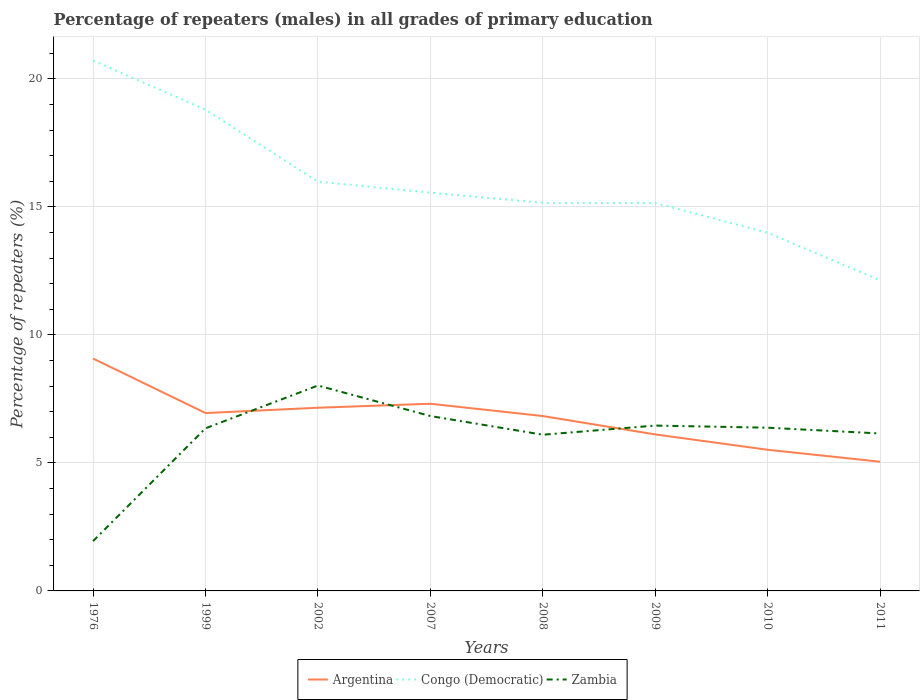Across all years, what is the maximum percentage of repeaters (males) in Congo (Democratic)?
Give a very brief answer. 12.13. In which year was the percentage of repeaters (males) in Argentina maximum?
Offer a terse response. 2011. What is the total percentage of repeaters (males) in Congo (Democratic) in the graph?
Ensure brevity in your answer.  3.86. What is the difference between the highest and the second highest percentage of repeaters (males) in Congo (Democratic)?
Make the answer very short. 8.58. What is the difference between the highest and the lowest percentage of repeaters (males) in Argentina?
Give a very brief answer. 5. How many lines are there?
Offer a very short reply. 3. Are the values on the major ticks of Y-axis written in scientific E-notation?
Ensure brevity in your answer.  No. Does the graph contain grids?
Your answer should be very brief. Yes. Where does the legend appear in the graph?
Provide a succinct answer. Bottom center. How many legend labels are there?
Make the answer very short. 3. What is the title of the graph?
Ensure brevity in your answer.  Percentage of repeaters (males) in all grades of primary education. What is the label or title of the X-axis?
Ensure brevity in your answer.  Years. What is the label or title of the Y-axis?
Give a very brief answer. Percentage of repeaters (%). What is the Percentage of repeaters (%) of Argentina in 1976?
Keep it short and to the point. 9.08. What is the Percentage of repeaters (%) in Congo (Democratic) in 1976?
Provide a succinct answer. 20.72. What is the Percentage of repeaters (%) of Zambia in 1976?
Ensure brevity in your answer.  1.95. What is the Percentage of repeaters (%) of Argentina in 1999?
Give a very brief answer. 6.95. What is the Percentage of repeaters (%) in Congo (Democratic) in 1999?
Keep it short and to the point. 18.8. What is the Percentage of repeaters (%) in Zambia in 1999?
Provide a short and direct response. 6.35. What is the Percentage of repeaters (%) in Argentina in 2002?
Your response must be concise. 7.16. What is the Percentage of repeaters (%) in Congo (Democratic) in 2002?
Provide a short and direct response. 15.99. What is the Percentage of repeaters (%) in Zambia in 2002?
Provide a succinct answer. 8.02. What is the Percentage of repeaters (%) in Argentina in 2007?
Your answer should be very brief. 7.31. What is the Percentage of repeaters (%) in Congo (Democratic) in 2007?
Your answer should be very brief. 15.56. What is the Percentage of repeaters (%) of Zambia in 2007?
Your answer should be compact. 6.83. What is the Percentage of repeaters (%) of Argentina in 2008?
Ensure brevity in your answer.  6.83. What is the Percentage of repeaters (%) in Congo (Democratic) in 2008?
Give a very brief answer. 15.16. What is the Percentage of repeaters (%) in Zambia in 2008?
Your answer should be compact. 6.1. What is the Percentage of repeaters (%) of Argentina in 2009?
Your answer should be compact. 6.11. What is the Percentage of repeaters (%) of Congo (Democratic) in 2009?
Give a very brief answer. 15.16. What is the Percentage of repeaters (%) in Zambia in 2009?
Offer a terse response. 6.46. What is the Percentage of repeaters (%) of Argentina in 2010?
Keep it short and to the point. 5.51. What is the Percentage of repeaters (%) of Congo (Democratic) in 2010?
Keep it short and to the point. 13.99. What is the Percentage of repeaters (%) of Zambia in 2010?
Offer a very short reply. 6.38. What is the Percentage of repeaters (%) of Argentina in 2011?
Offer a very short reply. 5.05. What is the Percentage of repeaters (%) of Congo (Democratic) in 2011?
Provide a short and direct response. 12.13. What is the Percentage of repeaters (%) in Zambia in 2011?
Keep it short and to the point. 6.15. Across all years, what is the maximum Percentage of repeaters (%) of Argentina?
Your answer should be compact. 9.08. Across all years, what is the maximum Percentage of repeaters (%) of Congo (Democratic)?
Offer a very short reply. 20.72. Across all years, what is the maximum Percentage of repeaters (%) in Zambia?
Your answer should be compact. 8.02. Across all years, what is the minimum Percentage of repeaters (%) of Argentina?
Ensure brevity in your answer.  5.05. Across all years, what is the minimum Percentage of repeaters (%) in Congo (Democratic)?
Your response must be concise. 12.13. Across all years, what is the minimum Percentage of repeaters (%) of Zambia?
Keep it short and to the point. 1.95. What is the total Percentage of repeaters (%) in Argentina in the graph?
Give a very brief answer. 54. What is the total Percentage of repeaters (%) of Congo (Democratic) in the graph?
Provide a succinct answer. 127.5. What is the total Percentage of repeaters (%) in Zambia in the graph?
Your response must be concise. 48.24. What is the difference between the Percentage of repeaters (%) in Argentina in 1976 and that in 1999?
Your answer should be very brief. 2.13. What is the difference between the Percentage of repeaters (%) in Congo (Democratic) in 1976 and that in 1999?
Your answer should be compact. 1.92. What is the difference between the Percentage of repeaters (%) of Zambia in 1976 and that in 1999?
Offer a terse response. -4.41. What is the difference between the Percentage of repeaters (%) in Argentina in 1976 and that in 2002?
Your answer should be compact. 1.92. What is the difference between the Percentage of repeaters (%) in Congo (Democratic) in 1976 and that in 2002?
Your answer should be very brief. 4.73. What is the difference between the Percentage of repeaters (%) of Zambia in 1976 and that in 2002?
Ensure brevity in your answer.  -6.08. What is the difference between the Percentage of repeaters (%) in Argentina in 1976 and that in 2007?
Ensure brevity in your answer.  1.77. What is the difference between the Percentage of repeaters (%) of Congo (Democratic) in 1976 and that in 2007?
Your response must be concise. 5.16. What is the difference between the Percentage of repeaters (%) in Zambia in 1976 and that in 2007?
Keep it short and to the point. -4.89. What is the difference between the Percentage of repeaters (%) in Argentina in 1976 and that in 2008?
Make the answer very short. 2.25. What is the difference between the Percentage of repeaters (%) in Congo (Democratic) in 1976 and that in 2008?
Give a very brief answer. 5.56. What is the difference between the Percentage of repeaters (%) in Zambia in 1976 and that in 2008?
Ensure brevity in your answer.  -4.16. What is the difference between the Percentage of repeaters (%) of Argentina in 1976 and that in 2009?
Your answer should be compact. 2.96. What is the difference between the Percentage of repeaters (%) of Congo (Democratic) in 1976 and that in 2009?
Your answer should be very brief. 5.56. What is the difference between the Percentage of repeaters (%) of Zambia in 1976 and that in 2009?
Offer a terse response. -4.51. What is the difference between the Percentage of repeaters (%) in Argentina in 1976 and that in 2010?
Your answer should be compact. 3.56. What is the difference between the Percentage of repeaters (%) in Congo (Democratic) in 1976 and that in 2010?
Provide a succinct answer. 6.72. What is the difference between the Percentage of repeaters (%) in Zambia in 1976 and that in 2010?
Offer a very short reply. -4.43. What is the difference between the Percentage of repeaters (%) of Argentina in 1976 and that in 2011?
Provide a short and direct response. 4.03. What is the difference between the Percentage of repeaters (%) of Congo (Democratic) in 1976 and that in 2011?
Make the answer very short. 8.58. What is the difference between the Percentage of repeaters (%) of Zambia in 1976 and that in 2011?
Provide a short and direct response. -4.21. What is the difference between the Percentage of repeaters (%) in Argentina in 1999 and that in 2002?
Keep it short and to the point. -0.21. What is the difference between the Percentage of repeaters (%) of Congo (Democratic) in 1999 and that in 2002?
Provide a short and direct response. 2.81. What is the difference between the Percentage of repeaters (%) of Zambia in 1999 and that in 2002?
Provide a succinct answer. -1.67. What is the difference between the Percentage of repeaters (%) of Argentina in 1999 and that in 2007?
Provide a short and direct response. -0.36. What is the difference between the Percentage of repeaters (%) in Congo (Democratic) in 1999 and that in 2007?
Your response must be concise. 3.24. What is the difference between the Percentage of repeaters (%) of Zambia in 1999 and that in 2007?
Keep it short and to the point. -0.48. What is the difference between the Percentage of repeaters (%) in Argentina in 1999 and that in 2008?
Ensure brevity in your answer.  0.12. What is the difference between the Percentage of repeaters (%) of Congo (Democratic) in 1999 and that in 2008?
Your answer should be very brief. 3.64. What is the difference between the Percentage of repeaters (%) in Zambia in 1999 and that in 2008?
Offer a terse response. 0.25. What is the difference between the Percentage of repeaters (%) of Argentina in 1999 and that in 2009?
Give a very brief answer. 0.84. What is the difference between the Percentage of repeaters (%) of Congo (Democratic) in 1999 and that in 2009?
Offer a very short reply. 3.64. What is the difference between the Percentage of repeaters (%) in Zambia in 1999 and that in 2009?
Your response must be concise. -0.11. What is the difference between the Percentage of repeaters (%) of Argentina in 1999 and that in 2010?
Provide a succinct answer. 1.43. What is the difference between the Percentage of repeaters (%) in Congo (Democratic) in 1999 and that in 2010?
Make the answer very short. 4.81. What is the difference between the Percentage of repeaters (%) of Zambia in 1999 and that in 2010?
Ensure brevity in your answer.  -0.02. What is the difference between the Percentage of repeaters (%) of Argentina in 1999 and that in 2011?
Make the answer very short. 1.9. What is the difference between the Percentage of repeaters (%) in Congo (Democratic) in 1999 and that in 2011?
Provide a short and direct response. 6.67. What is the difference between the Percentage of repeaters (%) in Zambia in 1999 and that in 2011?
Provide a succinct answer. 0.2. What is the difference between the Percentage of repeaters (%) of Argentina in 2002 and that in 2007?
Your answer should be compact. -0.16. What is the difference between the Percentage of repeaters (%) in Congo (Democratic) in 2002 and that in 2007?
Offer a very short reply. 0.43. What is the difference between the Percentage of repeaters (%) in Zambia in 2002 and that in 2007?
Your answer should be compact. 1.19. What is the difference between the Percentage of repeaters (%) in Argentina in 2002 and that in 2008?
Make the answer very short. 0.33. What is the difference between the Percentage of repeaters (%) of Congo (Democratic) in 2002 and that in 2008?
Offer a terse response. 0.83. What is the difference between the Percentage of repeaters (%) in Zambia in 2002 and that in 2008?
Provide a succinct answer. 1.92. What is the difference between the Percentage of repeaters (%) in Argentina in 2002 and that in 2009?
Your answer should be very brief. 1.04. What is the difference between the Percentage of repeaters (%) in Congo (Democratic) in 2002 and that in 2009?
Keep it short and to the point. 0.83. What is the difference between the Percentage of repeaters (%) in Zambia in 2002 and that in 2009?
Keep it short and to the point. 1.56. What is the difference between the Percentage of repeaters (%) of Argentina in 2002 and that in 2010?
Give a very brief answer. 1.64. What is the difference between the Percentage of repeaters (%) in Congo (Democratic) in 2002 and that in 2010?
Make the answer very short. 2. What is the difference between the Percentage of repeaters (%) in Zambia in 2002 and that in 2010?
Offer a very short reply. 1.65. What is the difference between the Percentage of repeaters (%) of Argentina in 2002 and that in 2011?
Your answer should be very brief. 2.11. What is the difference between the Percentage of repeaters (%) of Congo (Democratic) in 2002 and that in 2011?
Make the answer very short. 3.86. What is the difference between the Percentage of repeaters (%) of Zambia in 2002 and that in 2011?
Your answer should be very brief. 1.87. What is the difference between the Percentage of repeaters (%) of Argentina in 2007 and that in 2008?
Keep it short and to the point. 0.48. What is the difference between the Percentage of repeaters (%) of Congo (Democratic) in 2007 and that in 2008?
Provide a succinct answer. 0.4. What is the difference between the Percentage of repeaters (%) in Zambia in 2007 and that in 2008?
Your answer should be compact. 0.73. What is the difference between the Percentage of repeaters (%) in Argentina in 2007 and that in 2009?
Offer a terse response. 1.2. What is the difference between the Percentage of repeaters (%) in Congo (Democratic) in 2007 and that in 2009?
Provide a succinct answer. 0.4. What is the difference between the Percentage of repeaters (%) in Zambia in 2007 and that in 2009?
Make the answer very short. 0.37. What is the difference between the Percentage of repeaters (%) of Argentina in 2007 and that in 2010?
Offer a very short reply. 1.8. What is the difference between the Percentage of repeaters (%) of Congo (Democratic) in 2007 and that in 2010?
Make the answer very short. 1.56. What is the difference between the Percentage of repeaters (%) of Zambia in 2007 and that in 2010?
Provide a short and direct response. 0.46. What is the difference between the Percentage of repeaters (%) in Argentina in 2007 and that in 2011?
Your response must be concise. 2.26. What is the difference between the Percentage of repeaters (%) of Congo (Democratic) in 2007 and that in 2011?
Your response must be concise. 3.42. What is the difference between the Percentage of repeaters (%) of Zambia in 2007 and that in 2011?
Provide a short and direct response. 0.68. What is the difference between the Percentage of repeaters (%) of Argentina in 2008 and that in 2009?
Give a very brief answer. 0.72. What is the difference between the Percentage of repeaters (%) of Congo (Democratic) in 2008 and that in 2009?
Ensure brevity in your answer.  0. What is the difference between the Percentage of repeaters (%) in Zambia in 2008 and that in 2009?
Offer a very short reply. -0.36. What is the difference between the Percentage of repeaters (%) of Argentina in 2008 and that in 2010?
Provide a succinct answer. 1.32. What is the difference between the Percentage of repeaters (%) in Congo (Democratic) in 2008 and that in 2010?
Make the answer very short. 1.17. What is the difference between the Percentage of repeaters (%) of Zambia in 2008 and that in 2010?
Provide a succinct answer. -0.27. What is the difference between the Percentage of repeaters (%) of Argentina in 2008 and that in 2011?
Offer a very short reply. 1.78. What is the difference between the Percentage of repeaters (%) in Congo (Democratic) in 2008 and that in 2011?
Provide a succinct answer. 3.03. What is the difference between the Percentage of repeaters (%) of Zambia in 2008 and that in 2011?
Keep it short and to the point. -0.05. What is the difference between the Percentage of repeaters (%) in Argentina in 2009 and that in 2010?
Make the answer very short. 0.6. What is the difference between the Percentage of repeaters (%) in Congo (Democratic) in 2009 and that in 2010?
Your answer should be compact. 1.16. What is the difference between the Percentage of repeaters (%) in Zambia in 2009 and that in 2010?
Your answer should be compact. 0.08. What is the difference between the Percentage of repeaters (%) in Argentina in 2009 and that in 2011?
Offer a very short reply. 1.07. What is the difference between the Percentage of repeaters (%) in Congo (Democratic) in 2009 and that in 2011?
Make the answer very short. 3.02. What is the difference between the Percentage of repeaters (%) in Zambia in 2009 and that in 2011?
Make the answer very short. 0.31. What is the difference between the Percentage of repeaters (%) in Argentina in 2010 and that in 2011?
Your response must be concise. 0.47. What is the difference between the Percentage of repeaters (%) in Congo (Democratic) in 2010 and that in 2011?
Your response must be concise. 1.86. What is the difference between the Percentage of repeaters (%) in Zambia in 2010 and that in 2011?
Provide a short and direct response. 0.23. What is the difference between the Percentage of repeaters (%) of Argentina in 1976 and the Percentage of repeaters (%) of Congo (Democratic) in 1999?
Your answer should be very brief. -9.72. What is the difference between the Percentage of repeaters (%) of Argentina in 1976 and the Percentage of repeaters (%) of Zambia in 1999?
Offer a terse response. 2.72. What is the difference between the Percentage of repeaters (%) in Congo (Democratic) in 1976 and the Percentage of repeaters (%) in Zambia in 1999?
Offer a terse response. 14.36. What is the difference between the Percentage of repeaters (%) in Argentina in 1976 and the Percentage of repeaters (%) in Congo (Democratic) in 2002?
Provide a short and direct response. -6.91. What is the difference between the Percentage of repeaters (%) of Argentina in 1976 and the Percentage of repeaters (%) of Zambia in 2002?
Provide a succinct answer. 1.05. What is the difference between the Percentage of repeaters (%) in Congo (Democratic) in 1976 and the Percentage of repeaters (%) in Zambia in 2002?
Your response must be concise. 12.69. What is the difference between the Percentage of repeaters (%) in Argentina in 1976 and the Percentage of repeaters (%) in Congo (Democratic) in 2007?
Offer a terse response. -6.48. What is the difference between the Percentage of repeaters (%) in Argentina in 1976 and the Percentage of repeaters (%) in Zambia in 2007?
Offer a very short reply. 2.25. What is the difference between the Percentage of repeaters (%) of Congo (Democratic) in 1976 and the Percentage of repeaters (%) of Zambia in 2007?
Make the answer very short. 13.89. What is the difference between the Percentage of repeaters (%) of Argentina in 1976 and the Percentage of repeaters (%) of Congo (Democratic) in 2008?
Ensure brevity in your answer.  -6.08. What is the difference between the Percentage of repeaters (%) of Argentina in 1976 and the Percentage of repeaters (%) of Zambia in 2008?
Give a very brief answer. 2.98. What is the difference between the Percentage of repeaters (%) in Congo (Democratic) in 1976 and the Percentage of repeaters (%) in Zambia in 2008?
Your response must be concise. 14.62. What is the difference between the Percentage of repeaters (%) in Argentina in 1976 and the Percentage of repeaters (%) in Congo (Democratic) in 2009?
Your response must be concise. -6.08. What is the difference between the Percentage of repeaters (%) in Argentina in 1976 and the Percentage of repeaters (%) in Zambia in 2009?
Your answer should be compact. 2.62. What is the difference between the Percentage of repeaters (%) of Congo (Democratic) in 1976 and the Percentage of repeaters (%) of Zambia in 2009?
Your answer should be compact. 14.26. What is the difference between the Percentage of repeaters (%) of Argentina in 1976 and the Percentage of repeaters (%) of Congo (Democratic) in 2010?
Offer a very short reply. -4.92. What is the difference between the Percentage of repeaters (%) of Argentina in 1976 and the Percentage of repeaters (%) of Zambia in 2010?
Offer a very short reply. 2.7. What is the difference between the Percentage of repeaters (%) in Congo (Democratic) in 1976 and the Percentage of repeaters (%) in Zambia in 2010?
Your answer should be compact. 14.34. What is the difference between the Percentage of repeaters (%) in Argentina in 1976 and the Percentage of repeaters (%) in Congo (Democratic) in 2011?
Your answer should be compact. -3.06. What is the difference between the Percentage of repeaters (%) in Argentina in 1976 and the Percentage of repeaters (%) in Zambia in 2011?
Your answer should be compact. 2.93. What is the difference between the Percentage of repeaters (%) of Congo (Democratic) in 1976 and the Percentage of repeaters (%) of Zambia in 2011?
Keep it short and to the point. 14.57. What is the difference between the Percentage of repeaters (%) of Argentina in 1999 and the Percentage of repeaters (%) of Congo (Democratic) in 2002?
Make the answer very short. -9.04. What is the difference between the Percentage of repeaters (%) of Argentina in 1999 and the Percentage of repeaters (%) of Zambia in 2002?
Ensure brevity in your answer.  -1.08. What is the difference between the Percentage of repeaters (%) of Congo (Democratic) in 1999 and the Percentage of repeaters (%) of Zambia in 2002?
Provide a short and direct response. 10.77. What is the difference between the Percentage of repeaters (%) in Argentina in 1999 and the Percentage of repeaters (%) in Congo (Democratic) in 2007?
Your answer should be very brief. -8.61. What is the difference between the Percentage of repeaters (%) of Argentina in 1999 and the Percentage of repeaters (%) of Zambia in 2007?
Give a very brief answer. 0.12. What is the difference between the Percentage of repeaters (%) of Congo (Democratic) in 1999 and the Percentage of repeaters (%) of Zambia in 2007?
Make the answer very short. 11.97. What is the difference between the Percentage of repeaters (%) in Argentina in 1999 and the Percentage of repeaters (%) in Congo (Democratic) in 2008?
Your answer should be very brief. -8.21. What is the difference between the Percentage of repeaters (%) in Argentina in 1999 and the Percentage of repeaters (%) in Zambia in 2008?
Provide a succinct answer. 0.85. What is the difference between the Percentage of repeaters (%) in Congo (Democratic) in 1999 and the Percentage of repeaters (%) in Zambia in 2008?
Offer a terse response. 12.7. What is the difference between the Percentage of repeaters (%) in Argentina in 1999 and the Percentage of repeaters (%) in Congo (Democratic) in 2009?
Give a very brief answer. -8.21. What is the difference between the Percentage of repeaters (%) of Argentina in 1999 and the Percentage of repeaters (%) of Zambia in 2009?
Offer a very short reply. 0.49. What is the difference between the Percentage of repeaters (%) in Congo (Democratic) in 1999 and the Percentage of repeaters (%) in Zambia in 2009?
Your answer should be very brief. 12.34. What is the difference between the Percentage of repeaters (%) of Argentina in 1999 and the Percentage of repeaters (%) of Congo (Democratic) in 2010?
Ensure brevity in your answer.  -7.04. What is the difference between the Percentage of repeaters (%) of Argentina in 1999 and the Percentage of repeaters (%) of Zambia in 2010?
Ensure brevity in your answer.  0.57. What is the difference between the Percentage of repeaters (%) in Congo (Democratic) in 1999 and the Percentage of repeaters (%) in Zambia in 2010?
Provide a short and direct response. 12.42. What is the difference between the Percentage of repeaters (%) in Argentina in 1999 and the Percentage of repeaters (%) in Congo (Democratic) in 2011?
Your answer should be compact. -5.18. What is the difference between the Percentage of repeaters (%) in Argentina in 1999 and the Percentage of repeaters (%) in Zambia in 2011?
Give a very brief answer. 0.8. What is the difference between the Percentage of repeaters (%) of Congo (Democratic) in 1999 and the Percentage of repeaters (%) of Zambia in 2011?
Your response must be concise. 12.65. What is the difference between the Percentage of repeaters (%) in Argentina in 2002 and the Percentage of repeaters (%) in Congo (Democratic) in 2007?
Keep it short and to the point. -8.4. What is the difference between the Percentage of repeaters (%) of Argentina in 2002 and the Percentage of repeaters (%) of Zambia in 2007?
Offer a terse response. 0.32. What is the difference between the Percentage of repeaters (%) in Congo (Democratic) in 2002 and the Percentage of repeaters (%) in Zambia in 2007?
Provide a succinct answer. 9.16. What is the difference between the Percentage of repeaters (%) in Argentina in 2002 and the Percentage of repeaters (%) in Congo (Democratic) in 2008?
Your response must be concise. -8. What is the difference between the Percentage of repeaters (%) of Argentina in 2002 and the Percentage of repeaters (%) of Zambia in 2008?
Provide a short and direct response. 1.05. What is the difference between the Percentage of repeaters (%) of Congo (Democratic) in 2002 and the Percentage of repeaters (%) of Zambia in 2008?
Your answer should be very brief. 9.89. What is the difference between the Percentage of repeaters (%) of Argentina in 2002 and the Percentage of repeaters (%) of Congo (Democratic) in 2009?
Provide a succinct answer. -8. What is the difference between the Percentage of repeaters (%) in Argentina in 2002 and the Percentage of repeaters (%) in Zambia in 2009?
Your response must be concise. 0.7. What is the difference between the Percentage of repeaters (%) of Congo (Democratic) in 2002 and the Percentage of repeaters (%) of Zambia in 2009?
Ensure brevity in your answer.  9.53. What is the difference between the Percentage of repeaters (%) of Argentina in 2002 and the Percentage of repeaters (%) of Congo (Democratic) in 2010?
Offer a very short reply. -6.84. What is the difference between the Percentage of repeaters (%) of Argentina in 2002 and the Percentage of repeaters (%) of Zambia in 2010?
Ensure brevity in your answer.  0.78. What is the difference between the Percentage of repeaters (%) of Congo (Democratic) in 2002 and the Percentage of repeaters (%) of Zambia in 2010?
Provide a succinct answer. 9.61. What is the difference between the Percentage of repeaters (%) in Argentina in 2002 and the Percentage of repeaters (%) in Congo (Democratic) in 2011?
Keep it short and to the point. -4.98. What is the difference between the Percentage of repeaters (%) in Congo (Democratic) in 2002 and the Percentage of repeaters (%) in Zambia in 2011?
Ensure brevity in your answer.  9.84. What is the difference between the Percentage of repeaters (%) of Argentina in 2007 and the Percentage of repeaters (%) of Congo (Democratic) in 2008?
Offer a terse response. -7.85. What is the difference between the Percentage of repeaters (%) in Argentina in 2007 and the Percentage of repeaters (%) in Zambia in 2008?
Keep it short and to the point. 1.21. What is the difference between the Percentage of repeaters (%) in Congo (Democratic) in 2007 and the Percentage of repeaters (%) in Zambia in 2008?
Your answer should be compact. 9.46. What is the difference between the Percentage of repeaters (%) of Argentina in 2007 and the Percentage of repeaters (%) of Congo (Democratic) in 2009?
Provide a short and direct response. -7.84. What is the difference between the Percentage of repeaters (%) in Argentina in 2007 and the Percentage of repeaters (%) in Zambia in 2009?
Ensure brevity in your answer.  0.85. What is the difference between the Percentage of repeaters (%) in Congo (Democratic) in 2007 and the Percentage of repeaters (%) in Zambia in 2009?
Provide a short and direct response. 9.1. What is the difference between the Percentage of repeaters (%) in Argentina in 2007 and the Percentage of repeaters (%) in Congo (Democratic) in 2010?
Your answer should be very brief. -6.68. What is the difference between the Percentage of repeaters (%) of Argentina in 2007 and the Percentage of repeaters (%) of Zambia in 2010?
Offer a terse response. 0.94. What is the difference between the Percentage of repeaters (%) of Congo (Democratic) in 2007 and the Percentage of repeaters (%) of Zambia in 2010?
Your answer should be compact. 9.18. What is the difference between the Percentage of repeaters (%) in Argentina in 2007 and the Percentage of repeaters (%) in Congo (Democratic) in 2011?
Offer a terse response. -4.82. What is the difference between the Percentage of repeaters (%) of Argentina in 2007 and the Percentage of repeaters (%) of Zambia in 2011?
Your response must be concise. 1.16. What is the difference between the Percentage of repeaters (%) of Congo (Democratic) in 2007 and the Percentage of repeaters (%) of Zambia in 2011?
Your response must be concise. 9.41. What is the difference between the Percentage of repeaters (%) in Argentina in 2008 and the Percentage of repeaters (%) in Congo (Democratic) in 2009?
Give a very brief answer. -8.32. What is the difference between the Percentage of repeaters (%) in Argentina in 2008 and the Percentage of repeaters (%) in Zambia in 2009?
Make the answer very short. 0.37. What is the difference between the Percentage of repeaters (%) in Congo (Democratic) in 2008 and the Percentage of repeaters (%) in Zambia in 2009?
Your answer should be compact. 8.7. What is the difference between the Percentage of repeaters (%) in Argentina in 2008 and the Percentage of repeaters (%) in Congo (Democratic) in 2010?
Give a very brief answer. -7.16. What is the difference between the Percentage of repeaters (%) of Argentina in 2008 and the Percentage of repeaters (%) of Zambia in 2010?
Provide a short and direct response. 0.45. What is the difference between the Percentage of repeaters (%) of Congo (Democratic) in 2008 and the Percentage of repeaters (%) of Zambia in 2010?
Keep it short and to the point. 8.78. What is the difference between the Percentage of repeaters (%) in Argentina in 2008 and the Percentage of repeaters (%) in Congo (Democratic) in 2011?
Provide a succinct answer. -5.3. What is the difference between the Percentage of repeaters (%) in Argentina in 2008 and the Percentage of repeaters (%) in Zambia in 2011?
Your response must be concise. 0.68. What is the difference between the Percentage of repeaters (%) of Congo (Democratic) in 2008 and the Percentage of repeaters (%) of Zambia in 2011?
Your response must be concise. 9.01. What is the difference between the Percentage of repeaters (%) in Argentina in 2009 and the Percentage of repeaters (%) in Congo (Democratic) in 2010?
Your response must be concise. -7.88. What is the difference between the Percentage of repeaters (%) of Argentina in 2009 and the Percentage of repeaters (%) of Zambia in 2010?
Offer a terse response. -0.26. What is the difference between the Percentage of repeaters (%) in Congo (Democratic) in 2009 and the Percentage of repeaters (%) in Zambia in 2010?
Your answer should be compact. 8.78. What is the difference between the Percentage of repeaters (%) of Argentina in 2009 and the Percentage of repeaters (%) of Congo (Democratic) in 2011?
Your response must be concise. -6.02. What is the difference between the Percentage of repeaters (%) in Argentina in 2009 and the Percentage of repeaters (%) in Zambia in 2011?
Keep it short and to the point. -0.04. What is the difference between the Percentage of repeaters (%) of Congo (Democratic) in 2009 and the Percentage of repeaters (%) of Zambia in 2011?
Keep it short and to the point. 9.01. What is the difference between the Percentage of repeaters (%) of Argentina in 2010 and the Percentage of repeaters (%) of Congo (Democratic) in 2011?
Offer a terse response. -6.62. What is the difference between the Percentage of repeaters (%) in Argentina in 2010 and the Percentage of repeaters (%) in Zambia in 2011?
Provide a short and direct response. -0.64. What is the difference between the Percentage of repeaters (%) of Congo (Democratic) in 2010 and the Percentage of repeaters (%) of Zambia in 2011?
Your response must be concise. 7.84. What is the average Percentage of repeaters (%) of Argentina per year?
Your answer should be compact. 6.75. What is the average Percentage of repeaters (%) of Congo (Democratic) per year?
Your answer should be compact. 15.94. What is the average Percentage of repeaters (%) of Zambia per year?
Ensure brevity in your answer.  6.03. In the year 1976, what is the difference between the Percentage of repeaters (%) in Argentina and Percentage of repeaters (%) in Congo (Democratic)?
Give a very brief answer. -11.64. In the year 1976, what is the difference between the Percentage of repeaters (%) of Argentina and Percentage of repeaters (%) of Zambia?
Keep it short and to the point. 7.13. In the year 1976, what is the difference between the Percentage of repeaters (%) in Congo (Democratic) and Percentage of repeaters (%) in Zambia?
Provide a short and direct response. 18.77. In the year 1999, what is the difference between the Percentage of repeaters (%) of Argentina and Percentage of repeaters (%) of Congo (Democratic)?
Offer a very short reply. -11.85. In the year 1999, what is the difference between the Percentage of repeaters (%) of Argentina and Percentage of repeaters (%) of Zambia?
Keep it short and to the point. 0.6. In the year 1999, what is the difference between the Percentage of repeaters (%) in Congo (Democratic) and Percentage of repeaters (%) in Zambia?
Keep it short and to the point. 12.45. In the year 2002, what is the difference between the Percentage of repeaters (%) in Argentina and Percentage of repeaters (%) in Congo (Democratic)?
Keep it short and to the point. -8.83. In the year 2002, what is the difference between the Percentage of repeaters (%) in Argentina and Percentage of repeaters (%) in Zambia?
Make the answer very short. -0.87. In the year 2002, what is the difference between the Percentage of repeaters (%) of Congo (Democratic) and Percentage of repeaters (%) of Zambia?
Your answer should be compact. 7.96. In the year 2007, what is the difference between the Percentage of repeaters (%) of Argentina and Percentage of repeaters (%) of Congo (Democratic)?
Provide a short and direct response. -8.25. In the year 2007, what is the difference between the Percentage of repeaters (%) of Argentina and Percentage of repeaters (%) of Zambia?
Make the answer very short. 0.48. In the year 2007, what is the difference between the Percentage of repeaters (%) in Congo (Democratic) and Percentage of repeaters (%) in Zambia?
Offer a terse response. 8.73. In the year 2008, what is the difference between the Percentage of repeaters (%) of Argentina and Percentage of repeaters (%) of Congo (Democratic)?
Your answer should be very brief. -8.33. In the year 2008, what is the difference between the Percentage of repeaters (%) in Argentina and Percentage of repeaters (%) in Zambia?
Offer a terse response. 0.73. In the year 2008, what is the difference between the Percentage of repeaters (%) of Congo (Democratic) and Percentage of repeaters (%) of Zambia?
Your response must be concise. 9.06. In the year 2009, what is the difference between the Percentage of repeaters (%) in Argentina and Percentage of repeaters (%) in Congo (Democratic)?
Ensure brevity in your answer.  -9.04. In the year 2009, what is the difference between the Percentage of repeaters (%) in Argentina and Percentage of repeaters (%) in Zambia?
Your answer should be compact. -0.35. In the year 2009, what is the difference between the Percentage of repeaters (%) in Congo (Democratic) and Percentage of repeaters (%) in Zambia?
Give a very brief answer. 8.7. In the year 2010, what is the difference between the Percentage of repeaters (%) of Argentina and Percentage of repeaters (%) of Congo (Democratic)?
Keep it short and to the point. -8.48. In the year 2010, what is the difference between the Percentage of repeaters (%) in Argentina and Percentage of repeaters (%) in Zambia?
Ensure brevity in your answer.  -0.86. In the year 2010, what is the difference between the Percentage of repeaters (%) of Congo (Democratic) and Percentage of repeaters (%) of Zambia?
Provide a short and direct response. 7.62. In the year 2011, what is the difference between the Percentage of repeaters (%) of Argentina and Percentage of repeaters (%) of Congo (Democratic)?
Keep it short and to the point. -7.09. In the year 2011, what is the difference between the Percentage of repeaters (%) in Argentina and Percentage of repeaters (%) in Zambia?
Make the answer very short. -1.1. In the year 2011, what is the difference between the Percentage of repeaters (%) of Congo (Democratic) and Percentage of repeaters (%) of Zambia?
Keep it short and to the point. 5.98. What is the ratio of the Percentage of repeaters (%) of Argentina in 1976 to that in 1999?
Keep it short and to the point. 1.31. What is the ratio of the Percentage of repeaters (%) of Congo (Democratic) in 1976 to that in 1999?
Give a very brief answer. 1.1. What is the ratio of the Percentage of repeaters (%) of Zambia in 1976 to that in 1999?
Your answer should be very brief. 0.31. What is the ratio of the Percentage of repeaters (%) of Argentina in 1976 to that in 2002?
Offer a very short reply. 1.27. What is the ratio of the Percentage of repeaters (%) in Congo (Democratic) in 1976 to that in 2002?
Give a very brief answer. 1.3. What is the ratio of the Percentage of repeaters (%) in Zambia in 1976 to that in 2002?
Offer a very short reply. 0.24. What is the ratio of the Percentage of repeaters (%) in Argentina in 1976 to that in 2007?
Provide a succinct answer. 1.24. What is the ratio of the Percentage of repeaters (%) in Congo (Democratic) in 1976 to that in 2007?
Offer a very short reply. 1.33. What is the ratio of the Percentage of repeaters (%) of Zambia in 1976 to that in 2007?
Ensure brevity in your answer.  0.28. What is the ratio of the Percentage of repeaters (%) in Argentina in 1976 to that in 2008?
Your answer should be compact. 1.33. What is the ratio of the Percentage of repeaters (%) in Congo (Democratic) in 1976 to that in 2008?
Make the answer very short. 1.37. What is the ratio of the Percentage of repeaters (%) of Zambia in 1976 to that in 2008?
Provide a succinct answer. 0.32. What is the ratio of the Percentage of repeaters (%) of Argentina in 1976 to that in 2009?
Your answer should be very brief. 1.48. What is the ratio of the Percentage of repeaters (%) of Congo (Democratic) in 1976 to that in 2009?
Your answer should be compact. 1.37. What is the ratio of the Percentage of repeaters (%) in Zambia in 1976 to that in 2009?
Your answer should be very brief. 0.3. What is the ratio of the Percentage of repeaters (%) in Argentina in 1976 to that in 2010?
Offer a very short reply. 1.65. What is the ratio of the Percentage of repeaters (%) in Congo (Democratic) in 1976 to that in 2010?
Offer a terse response. 1.48. What is the ratio of the Percentage of repeaters (%) in Zambia in 1976 to that in 2010?
Offer a terse response. 0.31. What is the ratio of the Percentage of repeaters (%) in Argentina in 1976 to that in 2011?
Provide a short and direct response. 1.8. What is the ratio of the Percentage of repeaters (%) in Congo (Democratic) in 1976 to that in 2011?
Make the answer very short. 1.71. What is the ratio of the Percentage of repeaters (%) in Zambia in 1976 to that in 2011?
Offer a terse response. 0.32. What is the ratio of the Percentage of repeaters (%) in Argentina in 1999 to that in 2002?
Make the answer very short. 0.97. What is the ratio of the Percentage of repeaters (%) of Congo (Democratic) in 1999 to that in 2002?
Offer a terse response. 1.18. What is the ratio of the Percentage of repeaters (%) in Zambia in 1999 to that in 2002?
Your answer should be very brief. 0.79. What is the ratio of the Percentage of repeaters (%) in Argentina in 1999 to that in 2007?
Give a very brief answer. 0.95. What is the ratio of the Percentage of repeaters (%) in Congo (Democratic) in 1999 to that in 2007?
Give a very brief answer. 1.21. What is the ratio of the Percentage of repeaters (%) of Zambia in 1999 to that in 2007?
Offer a terse response. 0.93. What is the ratio of the Percentage of repeaters (%) in Argentina in 1999 to that in 2008?
Make the answer very short. 1.02. What is the ratio of the Percentage of repeaters (%) of Congo (Democratic) in 1999 to that in 2008?
Provide a short and direct response. 1.24. What is the ratio of the Percentage of repeaters (%) in Zambia in 1999 to that in 2008?
Keep it short and to the point. 1.04. What is the ratio of the Percentage of repeaters (%) in Argentina in 1999 to that in 2009?
Give a very brief answer. 1.14. What is the ratio of the Percentage of repeaters (%) of Congo (Democratic) in 1999 to that in 2009?
Give a very brief answer. 1.24. What is the ratio of the Percentage of repeaters (%) of Zambia in 1999 to that in 2009?
Offer a very short reply. 0.98. What is the ratio of the Percentage of repeaters (%) of Argentina in 1999 to that in 2010?
Give a very brief answer. 1.26. What is the ratio of the Percentage of repeaters (%) of Congo (Democratic) in 1999 to that in 2010?
Provide a succinct answer. 1.34. What is the ratio of the Percentage of repeaters (%) of Zambia in 1999 to that in 2010?
Give a very brief answer. 1. What is the ratio of the Percentage of repeaters (%) in Argentina in 1999 to that in 2011?
Give a very brief answer. 1.38. What is the ratio of the Percentage of repeaters (%) of Congo (Democratic) in 1999 to that in 2011?
Your answer should be compact. 1.55. What is the ratio of the Percentage of repeaters (%) of Zambia in 1999 to that in 2011?
Give a very brief answer. 1.03. What is the ratio of the Percentage of repeaters (%) in Argentina in 2002 to that in 2007?
Keep it short and to the point. 0.98. What is the ratio of the Percentage of repeaters (%) of Congo (Democratic) in 2002 to that in 2007?
Provide a short and direct response. 1.03. What is the ratio of the Percentage of repeaters (%) in Zambia in 2002 to that in 2007?
Your answer should be very brief. 1.17. What is the ratio of the Percentage of repeaters (%) of Argentina in 2002 to that in 2008?
Offer a terse response. 1.05. What is the ratio of the Percentage of repeaters (%) of Congo (Democratic) in 2002 to that in 2008?
Keep it short and to the point. 1.05. What is the ratio of the Percentage of repeaters (%) of Zambia in 2002 to that in 2008?
Ensure brevity in your answer.  1.31. What is the ratio of the Percentage of repeaters (%) of Argentina in 2002 to that in 2009?
Provide a short and direct response. 1.17. What is the ratio of the Percentage of repeaters (%) in Congo (Democratic) in 2002 to that in 2009?
Your answer should be very brief. 1.05. What is the ratio of the Percentage of repeaters (%) of Zambia in 2002 to that in 2009?
Give a very brief answer. 1.24. What is the ratio of the Percentage of repeaters (%) of Argentina in 2002 to that in 2010?
Keep it short and to the point. 1.3. What is the ratio of the Percentage of repeaters (%) in Congo (Democratic) in 2002 to that in 2010?
Keep it short and to the point. 1.14. What is the ratio of the Percentage of repeaters (%) in Zambia in 2002 to that in 2010?
Ensure brevity in your answer.  1.26. What is the ratio of the Percentage of repeaters (%) of Argentina in 2002 to that in 2011?
Offer a terse response. 1.42. What is the ratio of the Percentage of repeaters (%) in Congo (Democratic) in 2002 to that in 2011?
Offer a very short reply. 1.32. What is the ratio of the Percentage of repeaters (%) of Zambia in 2002 to that in 2011?
Your answer should be compact. 1.3. What is the ratio of the Percentage of repeaters (%) of Argentina in 2007 to that in 2008?
Offer a very short reply. 1.07. What is the ratio of the Percentage of repeaters (%) of Congo (Democratic) in 2007 to that in 2008?
Provide a short and direct response. 1.03. What is the ratio of the Percentage of repeaters (%) of Zambia in 2007 to that in 2008?
Give a very brief answer. 1.12. What is the ratio of the Percentage of repeaters (%) of Argentina in 2007 to that in 2009?
Your response must be concise. 1.2. What is the ratio of the Percentage of repeaters (%) of Congo (Democratic) in 2007 to that in 2009?
Make the answer very short. 1.03. What is the ratio of the Percentage of repeaters (%) of Zambia in 2007 to that in 2009?
Keep it short and to the point. 1.06. What is the ratio of the Percentage of repeaters (%) in Argentina in 2007 to that in 2010?
Give a very brief answer. 1.33. What is the ratio of the Percentage of repeaters (%) in Congo (Democratic) in 2007 to that in 2010?
Offer a very short reply. 1.11. What is the ratio of the Percentage of repeaters (%) of Zambia in 2007 to that in 2010?
Make the answer very short. 1.07. What is the ratio of the Percentage of repeaters (%) of Argentina in 2007 to that in 2011?
Offer a terse response. 1.45. What is the ratio of the Percentage of repeaters (%) in Congo (Democratic) in 2007 to that in 2011?
Give a very brief answer. 1.28. What is the ratio of the Percentage of repeaters (%) in Zambia in 2007 to that in 2011?
Your answer should be very brief. 1.11. What is the ratio of the Percentage of repeaters (%) in Argentina in 2008 to that in 2009?
Give a very brief answer. 1.12. What is the ratio of the Percentage of repeaters (%) of Congo (Democratic) in 2008 to that in 2009?
Your response must be concise. 1. What is the ratio of the Percentage of repeaters (%) in Zambia in 2008 to that in 2009?
Give a very brief answer. 0.94. What is the ratio of the Percentage of repeaters (%) of Argentina in 2008 to that in 2010?
Offer a very short reply. 1.24. What is the ratio of the Percentage of repeaters (%) of Congo (Democratic) in 2008 to that in 2010?
Offer a very short reply. 1.08. What is the ratio of the Percentage of repeaters (%) in Zambia in 2008 to that in 2010?
Provide a succinct answer. 0.96. What is the ratio of the Percentage of repeaters (%) in Argentina in 2008 to that in 2011?
Offer a very short reply. 1.35. What is the ratio of the Percentage of repeaters (%) of Congo (Democratic) in 2008 to that in 2011?
Your answer should be very brief. 1.25. What is the ratio of the Percentage of repeaters (%) in Zambia in 2008 to that in 2011?
Your answer should be very brief. 0.99. What is the ratio of the Percentage of repeaters (%) of Argentina in 2009 to that in 2010?
Your answer should be compact. 1.11. What is the ratio of the Percentage of repeaters (%) in Congo (Democratic) in 2009 to that in 2010?
Ensure brevity in your answer.  1.08. What is the ratio of the Percentage of repeaters (%) in Zambia in 2009 to that in 2010?
Provide a succinct answer. 1.01. What is the ratio of the Percentage of repeaters (%) in Argentina in 2009 to that in 2011?
Offer a very short reply. 1.21. What is the ratio of the Percentage of repeaters (%) of Congo (Democratic) in 2009 to that in 2011?
Give a very brief answer. 1.25. What is the ratio of the Percentage of repeaters (%) of Zambia in 2009 to that in 2011?
Provide a succinct answer. 1.05. What is the ratio of the Percentage of repeaters (%) of Argentina in 2010 to that in 2011?
Your response must be concise. 1.09. What is the ratio of the Percentage of repeaters (%) in Congo (Democratic) in 2010 to that in 2011?
Provide a succinct answer. 1.15. What is the ratio of the Percentage of repeaters (%) of Zambia in 2010 to that in 2011?
Provide a succinct answer. 1.04. What is the difference between the highest and the second highest Percentage of repeaters (%) of Argentina?
Offer a very short reply. 1.77. What is the difference between the highest and the second highest Percentage of repeaters (%) of Congo (Democratic)?
Your answer should be compact. 1.92. What is the difference between the highest and the second highest Percentage of repeaters (%) in Zambia?
Make the answer very short. 1.19. What is the difference between the highest and the lowest Percentage of repeaters (%) of Argentina?
Your answer should be very brief. 4.03. What is the difference between the highest and the lowest Percentage of repeaters (%) in Congo (Democratic)?
Make the answer very short. 8.58. What is the difference between the highest and the lowest Percentage of repeaters (%) of Zambia?
Your response must be concise. 6.08. 